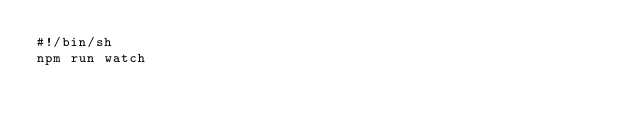<code> <loc_0><loc_0><loc_500><loc_500><_Bash_>#!/bin/sh
npm run watch
</code> 